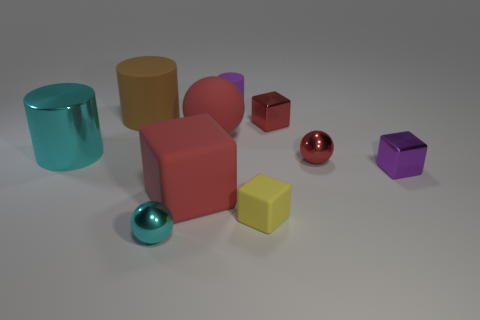There is a small block that is the same color as the tiny matte cylinder; what is its material?
Offer a very short reply. Metal. What number of objects are either big red objects that are in front of the shiny cylinder or purple cubes?
Ensure brevity in your answer.  2. There is a small thing behind the tiny red block; what shape is it?
Offer a very short reply. Cylinder. Are there the same number of red metal things to the left of the big block and tiny rubber things right of the large red ball?
Offer a very short reply. No. What color is the matte object that is both in front of the red shiny cube and to the left of the large red sphere?
Offer a terse response. Red. There is a sphere that is on the left side of the red block that is on the left side of the large matte ball; what is it made of?
Offer a very short reply. Metal. Is the red metallic cube the same size as the purple block?
Offer a terse response. Yes. What number of small things are cyan shiny things or cyan metal cylinders?
Provide a short and direct response. 1. What number of yellow cubes are to the right of the cyan sphere?
Your response must be concise. 1. Is the number of small purple metal cubes on the left side of the small purple matte thing greater than the number of red metal spheres?
Provide a succinct answer. No. 